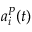<formula> <loc_0><loc_0><loc_500><loc_500>a _ { i } ^ { P } ( t )</formula> 